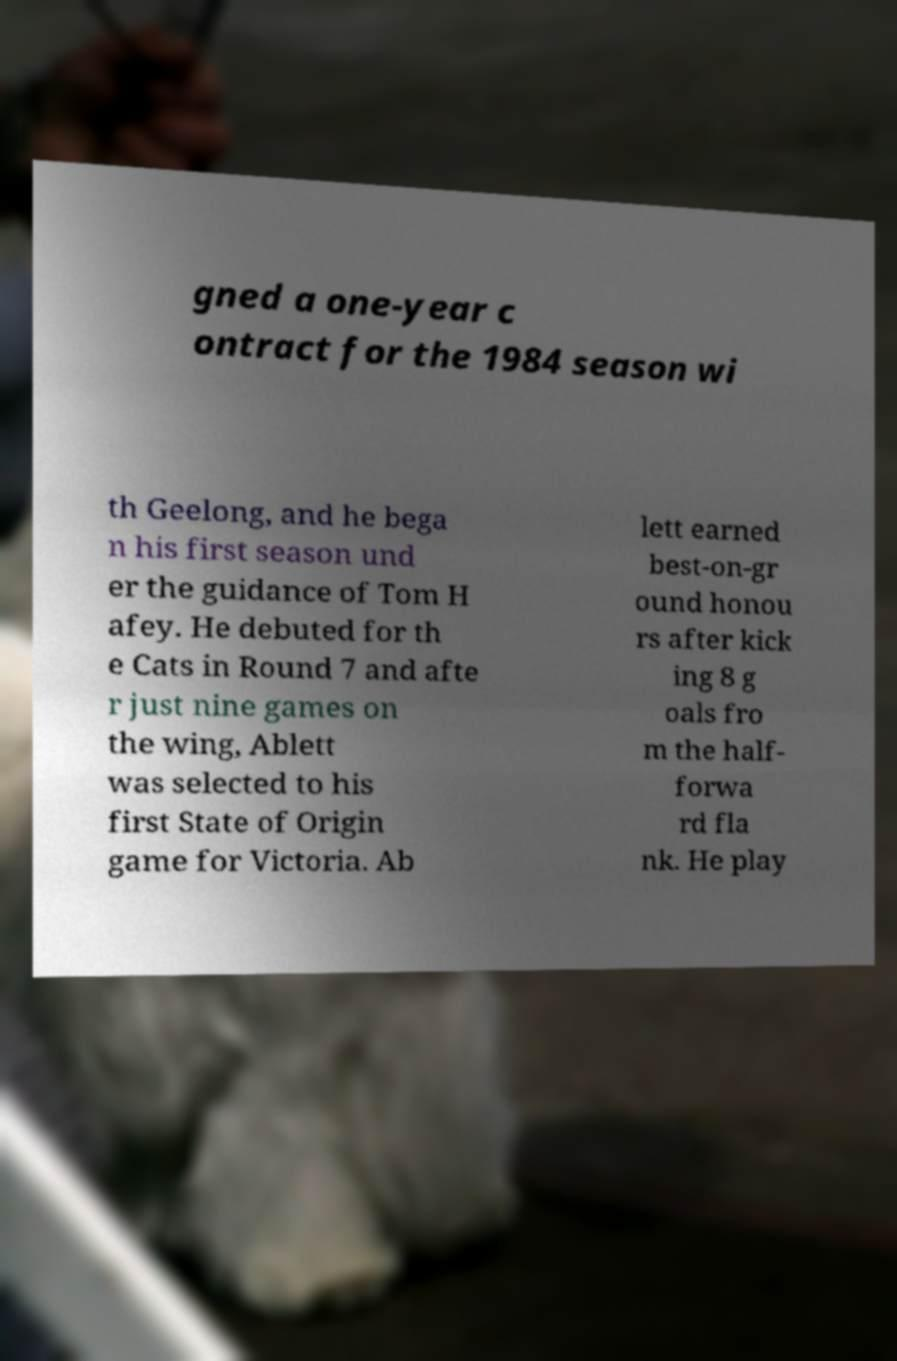Could you extract and type out the text from this image? gned a one-year c ontract for the 1984 season wi th Geelong, and he bega n his first season und er the guidance of Tom H afey. He debuted for th e Cats in Round 7 and afte r just nine games on the wing, Ablett was selected to his first State of Origin game for Victoria. Ab lett earned best-on-gr ound honou rs after kick ing 8 g oals fro m the half- forwa rd fla nk. He play 